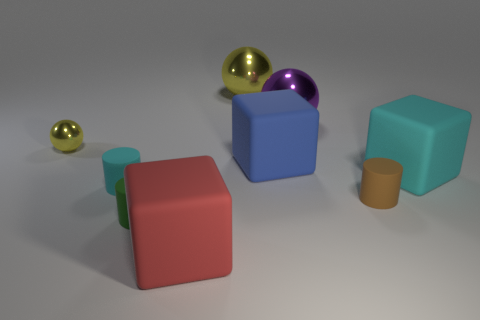Add 1 big cyan matte cubes. How many objects exist? 10 Subtract all cylinders. How many objects are left? 6 Add 6 big cyan metal cylinders. How many big cyan metal cylinders exist? 6 Subtract 1 cyan cylinders. How many objects are left? 8 Subtract all tiny yellow matte things. Subtract all yellow shiny spheres. How many objects are left? 7 Add 7 red rubber cubes. How many red rubber cubes are left? 8 